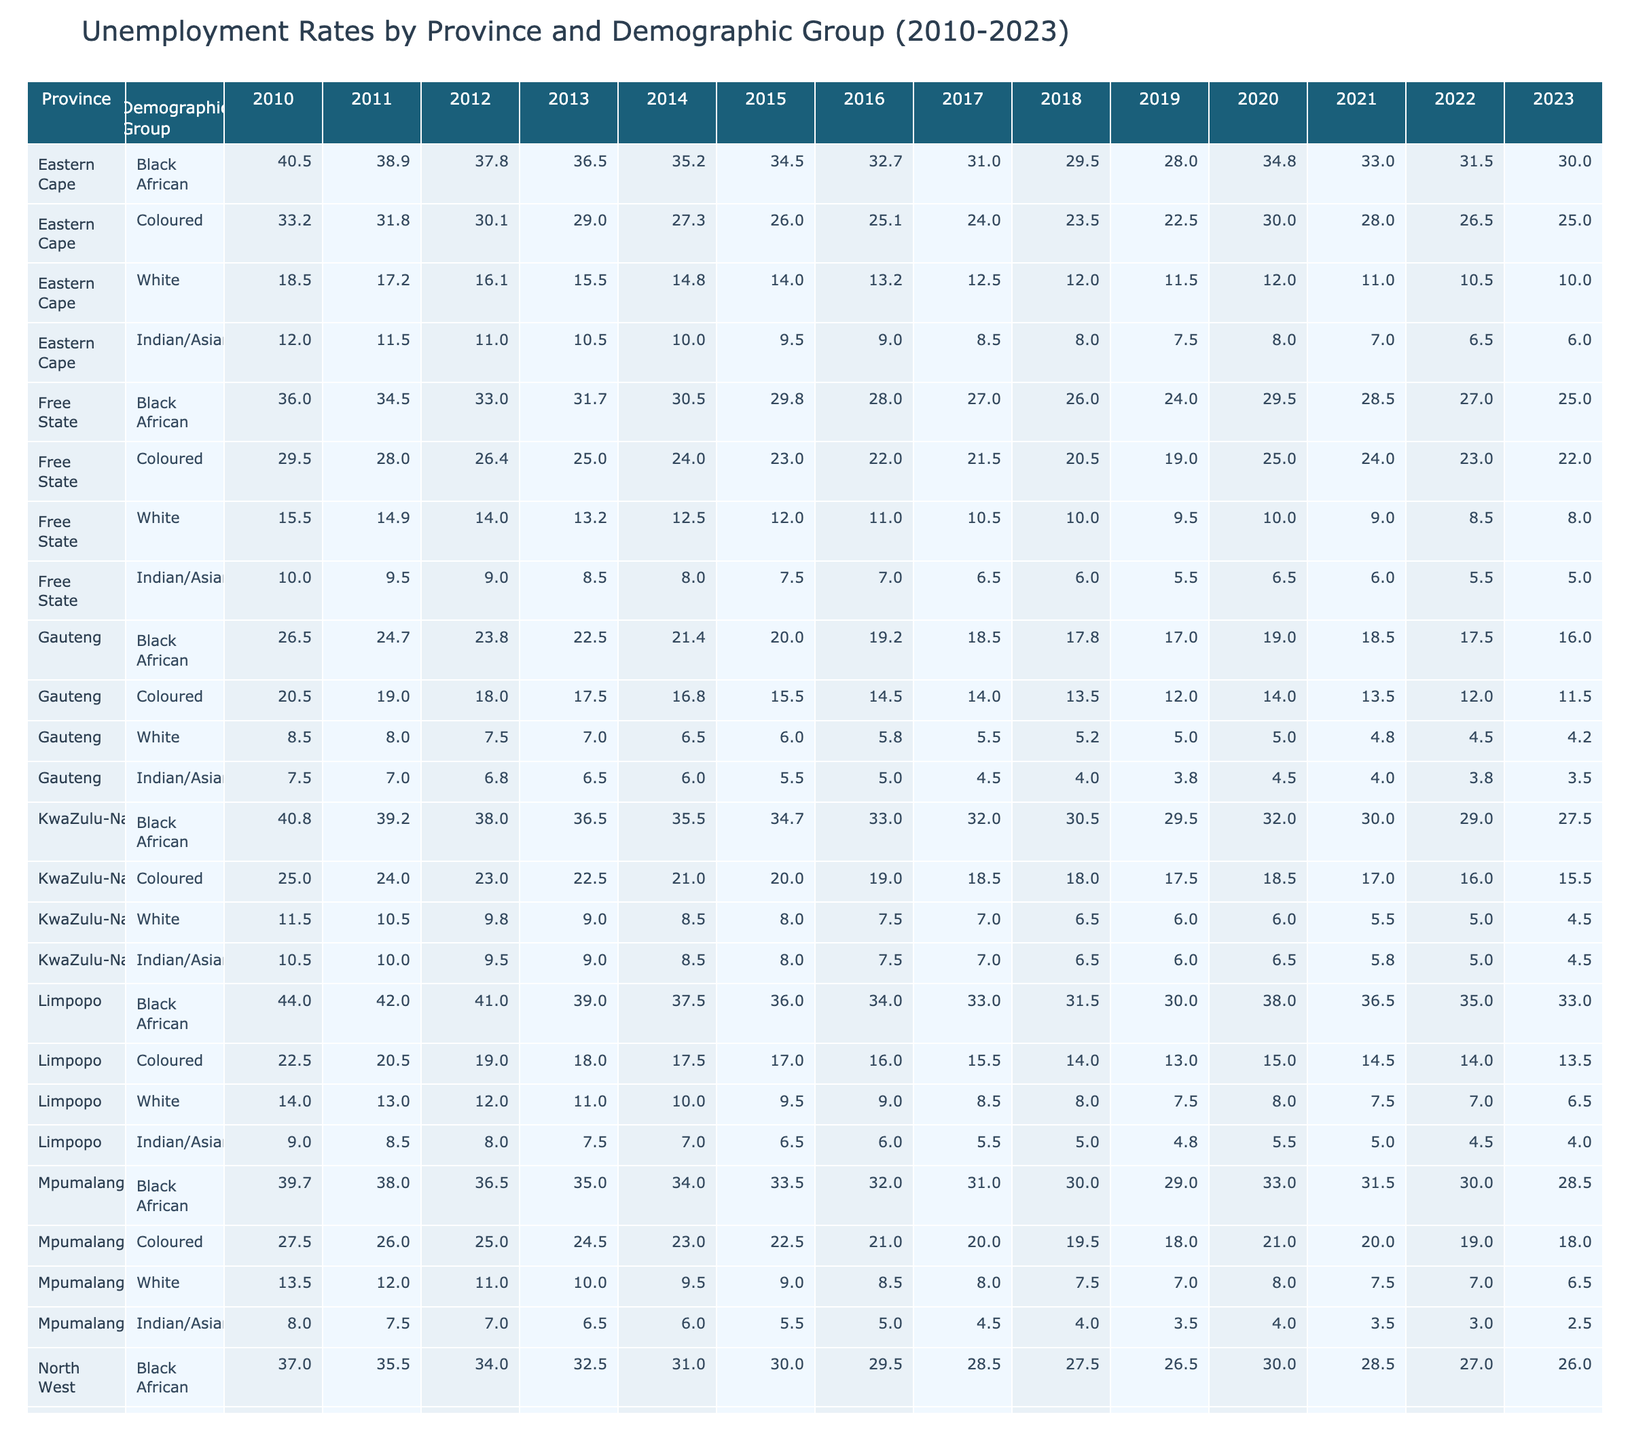What was the unemployment rate for Black African individuals in Gauteng in 2023? The unemployment rate for Black African individuals in Gauteng in 2023 is found in the row corresponding to Gauteng and the Black African demographic group. According to the table, this value is 16.0.
Answer: 16.0 Which province had the highest unemployment rate for the White demographic group in 2010? To find this, I compare the unemployment rates for the White demographic across all provinces in 2010. The rates are: Eastern Cape (18.5), Free State (15.5), Gauteng (8.5), KwaZulu-Natal (11.5), Limpopo (14.0), Mpumalanga (13.5), North West (11.0), and Northern Cape (15.0). The highest rate is 18.5 in the Eastern Cape.
Answer: Eastern Cape What is the difference in unemployment rates for Coloured individuals between Northern Cape and Mpumalanga in 2022? The unemployment rate for Coloured individuals in Northern Cape in 2022 is 23.0, and in Mpumalanga, it is 19.0. Calculating the difference gives 23.0 - 19.0 = 4.0.
Answer: 4.0 Did the unemployment rate for Indian/Asian individuals in the Eastern Cape decrease from 2010 to 2023? In 2010, the unemployment rate for Indian/Asian individuals in the Eastern Cape was 12.0, and in 2023 it is 6.0. Since 6.0 is lower than 12.0, the rate did indeed decrease.
Answer: Yes What was the average unemployment rate for Black African individuals across all provinces in 2021? To find the average, I first list the unemployment rates for Black African individuals in all provinces for 2021: 33.0 (Eastern Cape), 28.5 (Free State), 18.5 (Gauteng), 30.0 (KwaZulu-Natal), 36.5 (Limpopo), 31.5 (Mpumalanga), 28.5 (North West), and 27.0 (Northern Cape). Summing these gives (33.0 + 28.5 + 18.5 + 30.0 + 36.5 + 31.5 + 28.5 + 27.0) =  304.5. There are 8 values, so the average is 304.5 / 8 = 38.06.
Answer: 38.06 In which year did the unemployment rate for Black African individuals in Limpopo first fall below 35%? Looking at the Limpopo row for Black African individuals, the rates are: 44.0 (2010), 42.0 (2011), 41.0 (2012), 39.0 (2013), 37.5 (2014), 36.0 (2015), 34.0 (2016), 33.0 (2017), 31.5 (2018), 30.0 (2019), 38.0 (2020), 36.5 (2021), 35.0 (2022), and 33.0 (2023). The first year the rate falls below 35% is 2016.
Answer: 2016 What is the trend in the unemployment rate for Coloured individuals in KwaZulu-Natal from 2010 to 2023? The unemployment rates for Coloured individuals in KwaZulu-Natal over the years are 25.0 (2010), 24.0 (2011), 23.0 (2012), 22.5 (2013), 21.0 (2014), 20.0 (2015), 19.0 (2016), 18.5 (2017), 18.0 (2018), 17.5 (2019), 18.5 (2020), 17.0 (2021), 16.0 (2022), 15.5 (2023). The trend shows a general decline from 2010 to 2019, a slight increase in 2020, followed by a decrease until 2023.
Answer: General decline with fluctuations Which demographic group showed the largest unemployment rate decrease in Mpumalanga from 2010 to 2023? Reviewing the unemployment rates for each demographic in Mpumalanga from 2010 to 2023, we have: Black African (39.7 to 28.5, decrease of 11.2), Coloured (27.5 to 18.0, decrease of 9.5), White (13.5 to 6.5, decrease of 7.0), and Indian/Asian (8.0 to 2.5, decrease of 5.5). The largest decrease is for Black African individuals, with a decrease of 11.2.
Answer: Black African Which province had the lowest unemployment rate for the White demographic group in 2023? Checking the unemployment rates for the White demographic group in 2023, we find: Eastern Cape (10.0), Free State (8.0), Gauteng (4.2), KwaZulu-Natal (4.5), Limpopo (6.5), Mpumalanga (6.5), North West (4.5), and Northern Cape (8.5). The lowest rate is in Gauteng at 4.2.
Answer: Gauteng 